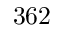Convert formula to latex. <formula><loc_0><loc_0><loc_500><loc_500>3 6 2</formula> 